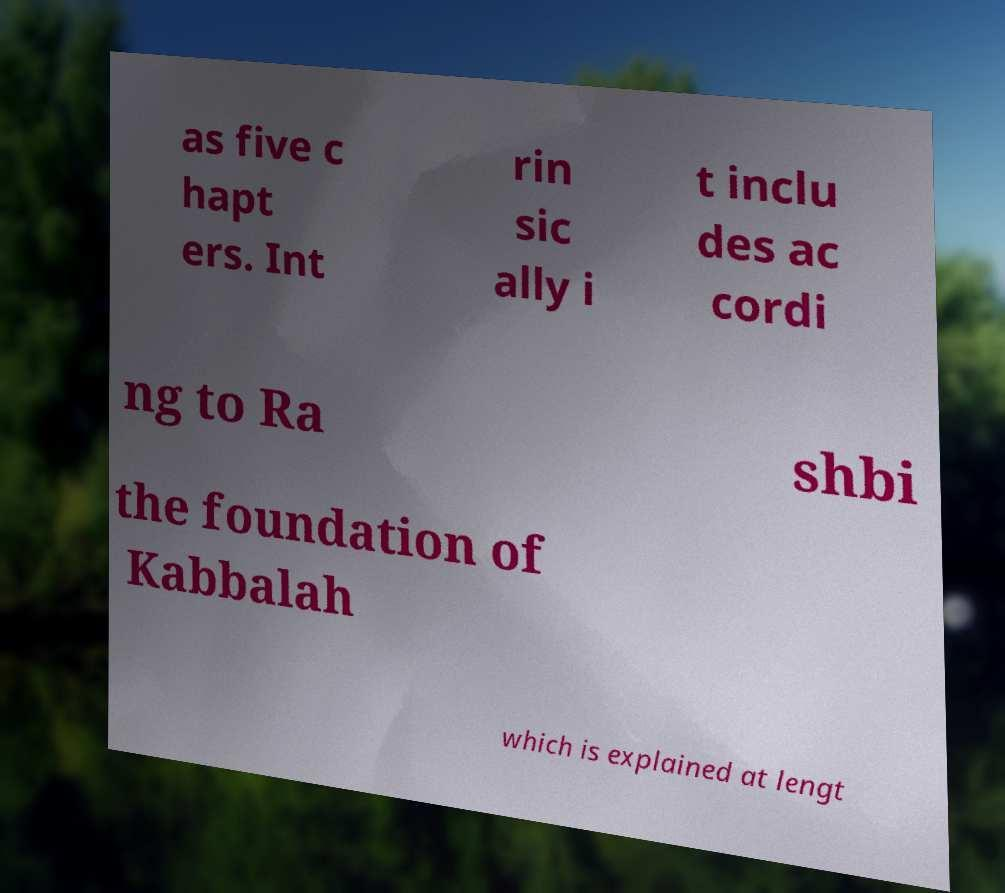For documentation purposes, I need the text within this image transcribed. Could you provide that? as five c hapt ers. Int rin sic ally i t inclu des ac cordi ng to Ra shbi the foundation of Kabbalah which is explained at lengt 